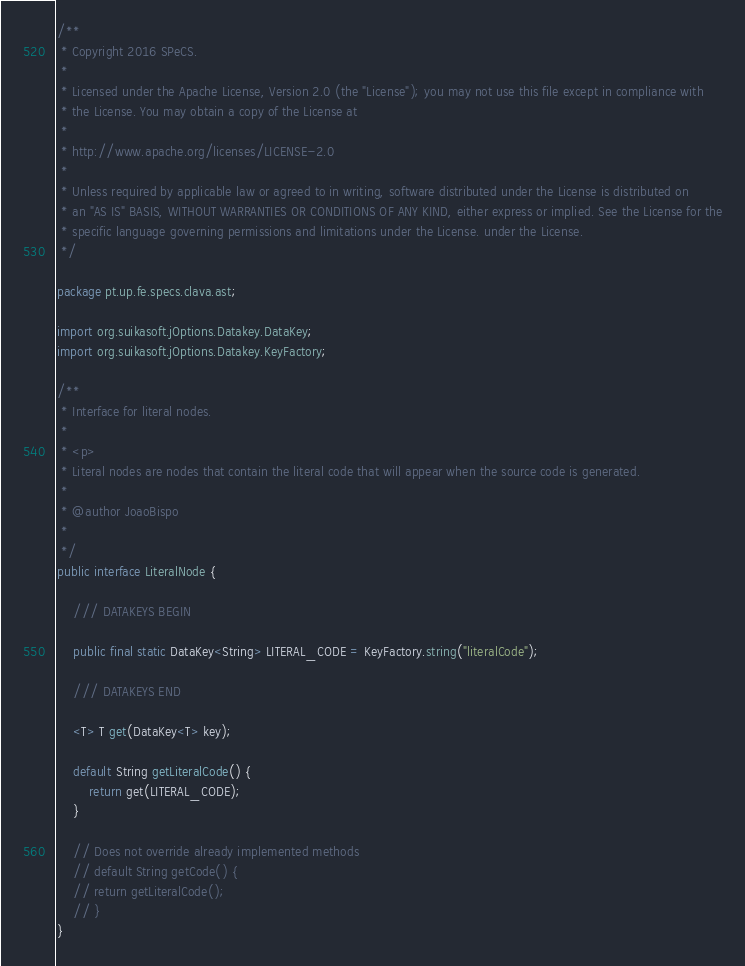Convert code to text. <code><loc_0><loc_0><loc_500><loc_500><_Java_>/**
 * Copyright 2016 SPeCS.
 * 
 * Licensed under the Apache License, Version 2.0 (the "License"); you may not use this file except in compliance with
 * the License. You may obtain a copy of the License at
 * 
 * http://www.apache.org/licenses/LICENSE-2.0
 * 
 * Unless required by applicable law or agreed to in writing, software distributed under the License is distributed on
 * an "AS IS" BASIS, WITHOUT WARRANTIES OR CONDITIONS OF ANY KIND, either express or implied. See the License for the
 * specific language governing permissions and limitations under the License. under the License.
 */

package pt.up.fe.specs.clava.ast;

import org.suikasoft.jOptions.Datakey.DataKey;
import org.suikasoft.jOptions.Datakey.KeyFactory;

/**
 * Interface for literal nodes.
 * 
 * <p>
 * Literal nodes are nodes that contain the literal code that will appear when the source code is generated.
 * 
 * @author JoaoBispo
 *
 */
public interface LiteralNode {

    /// DATAKEYS BEGIN

    public final static DataKey<String> LITERAL_CODE = KeyFactory.string("literalCode");

    /// DATAKEYS END

    <T> T get(DataKey<T> key);

    default String getLiteralCode() {
        return get(LITERAL_CODE);
    }

    // Does not override already implemented methods
    // default String getCode() {
    // return getLiteralCode();
    // }
}
</code> 